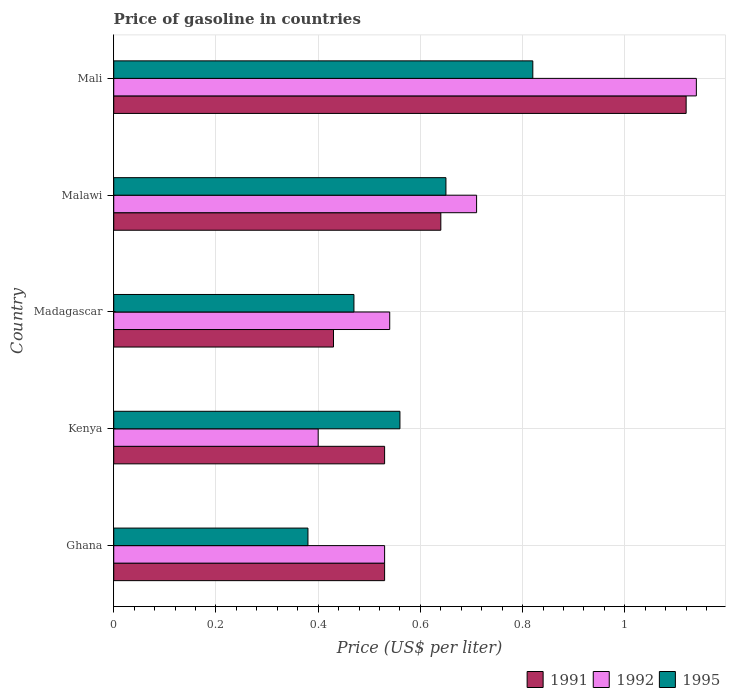Are the number of bars per tick equal to the number of legend labels?
Offer a terse response. Yes. Are the number of bars on each tick of the Y-axis equal?
Offer a very short reply. Yes. How many bars are there on the 4th tick from the top?
Ensure brevity in your answer.  3. How many bars are there on the 2nd tick from the bottom?
Offer a terse response. 3. What is the label of the 1st group of bars from the top?
Provide a succinct answer. Mali. In how many cases, is the number of bars for a given country not equal to the number of legend labels?
Keep it short and to the point. 0. What is the price of gasoline in 1992 in Ghana?
Ensure brevity in your answer.  0.53. Across all countries, what is the maximum price of gasoline in 1991?
Keep it short and to the point. 1.12. Across all countries, what is the minimum price of gasoline in 1991?
Offer a terse response. 0.43. In which country was the price of gasoline in 1992 maximum?
Offer a very short reply. Mali. In which country was the price of gasoline in 1992 minimum?
Provide a short and direct response. Kenya. What is the total price of gasoline in 1991 in the graph?
Keep it short and to the point. 3.25. What is the difference between the price of gasoline in 1995 in Madagascar and that in Mali?
Your response must be concise. -0.35. What is the difference between the price of gasoline in 1991 in Ghana and the price of gasoline in 1992 in Kenya?
Provide a succinct answer. 0.13. What is the average price of gasoline in 1995 per country?
Make the answer very short. 0.58. What is the difference between the price of gasoline in 1992 and price of gasoline in 1991 in Mali?
Your answer should be very brief. 0.02. In how many countries, is the price of gasoline in 1992 greater than 0.44 US$?
Your response must be concise. 4. What is the ratio of the price of gasoline in 1992 in Kenya to that in Madagascar?
Provide a short and direct response. 0.74. Is the price of gasoline in 1995 in Kenya less than that in Madagascar?
Keep it short and to the point. No. Is the difference between the price of gasoline in 1992 in Kenya and Mali greater than the difference between the price of gasoline in 1991 in Kenya and Mali?
Ensure brevity in your answer.  No. What is the difference between the highest and the second highest price of gasoline in 1992?
Keep it short and to the point. 0.43. What is the difference between the highest and the lowest price of gasoline in 1995?
Make the answer very short. 0.44. What does the 1st bar from the bottom in Malawi represents?
Make the answer very short. 1991. Is it the case that in every country, the sum of the price of gasoline in 1995 and price of gasoline in 1992 is greater than the price of gasoline in 1991?
Your answer should be compact. Yes. How many bars are there?
Give a very brief answer. 15. Does the graph contain any zero values?
Offer a very short reply. No. Where does the legend appear in the graph?
Make the answer very short. Bottom right. How many legend labels are there?
Your answer should be compact. 3. What is the title of the graph?
Provide a short and direct response. Price of gasoline in countries. Does "1996" appear as one of the legend labels in the graph?
Offer a very short reply. No. What is the label or title of the X-axis?
Keep it short and to the point. Price (US$ per liter). What is the label or title of the Y-axis?
Offer a very short reply. Country. What is the Price (US$ per liter) in 1991 in Ghana?
Offer a terse response. 0.53. What is the Price (US$ per liter) in 1992 in Ghana?
Your response must be concise. 0.53. What is the Price (US$ per liter) of 1995 in Ghana?
Your answer should be very brief. 0.38. What is the Price (US$ per liter) of 1991 in Kenya?
Your response must be concise. 0.53. What is the Price (US$ per liter) in 1992 in Kenya?
Provide a succinct answer. 0.4. What is the Price (US$ per liter) of 1995 in Kenya?
Provide a succinct answer. 0.56. What is the Price (US$ per liter) of 1991 in Madagascar?
Provide a succinct answer. 0.43. What is the Price (US$ per liter) in 1992 in Madagascar?
Offer a terse response. 0.54. What is the Price (US$ per liter) of 1995 in Madagascar?
Offer a very short reply. 0.47. What is the Price (US$ per liter) of 1991 in Malawi?
Your response must be concise. 0.64. What is the Price (US$ per liter) of 1992 in Malawi?
Make the answer very short. 0.71. What is the Price (US$ per liter) in 1995 in Malawi?
Your answer should be compact. 0.65. What is the Price (US$ per liter) of 1991 in Mali?
Your answer should be compact. 1.12. What is the Price (US$ per liter) of 1992 in Mali?
Offer a very short reply. 1.14. What is the Price (US$ per liter) of 1995 in Mali?
Provide a succinct answer. 0.82. Across all countries, what is the maximum Price (US$ per liter) of 1991?
Offer a very short reply. 1.12. Across all countries, what is the maximum Price (US$ per liter) in 1992?
Provide a short and direct response. 1.14. Across all countries, what is the maximum Price (US$ per liter) in 1995?
Offer a terse response. 0.82. Across all countries, what is the minimum Price (US$ per liter) of 1991?
Your answer should be very brief. 0.43. Across all countries, what is the minimum Price (US$ per liter) of 1992?
Offer a terse response. 0.4. Across all countries, what is the minimum Price (US$ per liter) of 1995?
Your answer should be compact. 0.38. What is the total Price (US$ per liter) in 1992 in the graph?
Give a very brief answer. 3.32. What is the total Price (US$ per liter) in 1995 in the graph?
Offer a terse response. 2.88. What is the difference between the Price (US$ per liter) of 1991 in Ghana and that in Kenya?
Keep it short and to the point. 0. What is the difference between the Price (US$ per liter) in 1992 in Ghana and that in Kenya?
Your answer should be compact. 0.13. What is the difference between the Price (US$ per liter) in 1995 in Ghana and that in Kenya?
Give a very brief answer. -0.18. What is the difference between the Price (US$ per liter) of 1991 in Ghana and that in Madagascar?
Make the answer very short. 0.1. What is the difference between the Price (US$ per liter) of 1992 in Ghana and that in Madagascar?
Your answer should be compact. -0.01. What is the difference between the Price (US$ per liter) of 1995 in Ghana and that in Madagascar?
Your response must be concise. -0.09. What is the difference between the Price (US$ per liter) of 1991 in Ghana and that in Malawi?
Give a very brief answer. -0.11. What is the difference between the Price (US$ per liter) of 1992 in Ghana and that in Malawi?
Your response must be concise. -0.18. What is the difference between the Price (US$ per liter) of 1995 in Ghana and that in Malawi?
Provide a succinct answer. -0.27. What is the difference between the Price (US$ per liter) in 1991 in Ghana and that in Mali?
Offer a terse response. -0.59. What is the difference between the Price (US$ per liter) in 1992 in Ghana and that in Mali?
Provide a succinct answer. -0.61. What is the difference between the Price (US$ per liter) of 1995 in Ghana and that in Mali?
Give a very brief answer. -0.44. What is the difference between the Price (US$ per liter) in 1992 in Kenya and that in Madagascar?
Offer a terse response. -0.14. What is the difference between the Price (US$ per liter) of 1995 in Kenya and that in Madagascar?
Keep it short and to the point. 0.09. What is the difference between the Price (US$ per liter) of 1991 in Kenya and that in Malawi?
Ensure brevity in your answer.  -0.11. What is the difference between the Price (US$ per liter) of 1992 in Kenya and that in Malawi?
Your response must be concise. -0.31. What is the difference between the Price (US$ per liter) of 1995 in Kenya and that in Malawi?
Offer a very short reply. -0.09. What is the difference between the Price (US$ per liter) of 1991 in Kenya and that in Mali?
Your answer should be compact. -0.59. What is the difference between the Price (US$ per liter) of 1992 in Kenya and that in Mali?
Your answer should be compact. -0.74. What is the difference between the Price (US$ per liter) of 1995 in Kenya and that in Mali?
Offer a terse response. -0.26. What is the difference between the Price (US$ per liter) of 1991 in Madagascar and that in Malawi?
Offer a very short reply. -0.21. What is the difference between the Price (US$ per liter) in 1992 in Madagascar and that in Malawi?
Offer a terse response. -0.17. What is the difference between the Price (US$ per liter) of 1995 in Madagascar and that in Malawi?
Keep it short and to the point. -0.18. What is the difference between the Price (US$ per liter) in 1991 in Madagascar and that in Mali?
Provide a succinct answer. -0.69. What is the difference between the Price (US$ per liter) of 1995 in Madagascar and that in Mali?
Provide a succinct answer. -0.35. What is the difference between the Price (US$ per liter) in 1991 in Malawi and that in Mali?
Provide a succinct answer. -0.48. What is the difference between the Price (US$ per liter) of 1992 in Malawi and that in Mali?
Provide a succinct answer. -0.43. What is the difference between the Price (US$ per liter) of 1995 in Malawi and that in Mali?
Offer a terse response. -0.17. What is the difference between the Price (US$ per liter) in 1991 in Ghana and the Price (US$ per liter) in 1992 in Kenya?
Your response must be concise. 0.13. What is the difference between the Price (US$ per liter) in 1991 in Ghana and the Price (US$ per liter) in 1995 in Kenya?
Your answer should be very brief. -0.03. What is the difference between the Price (US$ per liter) in 1992 in Ghana and the Price (US$ per liter) in 1995 in Kenya?
Keep it short and to the point. -0.03. What is the difference between the Price (US$ per liter) of 1991 in Ghana and the Price (US$ per liter) of 1992 in Madagascar?
Provide a short and direct response. -0.01. What is the difference between the Price (US$ per liter) in 1991 in Ghana and the Price (US$ per liter) in 1995 in Madagascar?
Your response must be concise. 0.06. What is the difference between the Price (US$ per liter) of 1992 in Ghana and the Price (US$ per liter) of 1995 in Madagascar?
Your answer should be very brief. 0.06. What is the difference between the Price (US$ per liter) in 1991 in Ghana and the Price (US$ per liter) in 1992 in Malawi?
Offer a very short reply. -0.18. What is the difference between the Price (US$ per liter) of 1991 in Ghana and the Price (US$ per liter) of 1995 in Malawi?
Provide a succinct answer. -0.12. What is the difference between the Price (US$ per liter) in 1992 in Ghana and the Price (US$ per liter) in 1995 in Malawi?
Offer a very short reply. -0.12. What is the difference between the Price (US$ per liter) of 1991 in Ghana and the Price (US$ per liter) of 1992 in Mali?
Ensure brevity in your answer.  -0.61. What is the difference between the Price (US$ per liter) in 1991 in Ghana and the Price (US$ per liter) in 1995 in Mali?
Your answer should be very brief. -0.29. What is the difference between the Price (US$ per liter) in 1992 in Ghana and the Price (US$ per liter) in 1995 in Mali?
Keep it short and to the point. -0.29. What is the difference between the Price (US$ per liter) in 1991 in Kenya and the Price (US$ per liter) in 1992 in Madagascar?
Offer a terse response. -0.01. What is the difference between the Price (US$ per liter) of 1992 in Kenya and the Price (US$ per liter) of 1995 in Madagascar?
Your answer should be very brief. -0.07. What is the difference between the Price (US$ per liter) in 1991 in Kenya and the Price (US$ per liter) in 1992 in Malawi?
Offer a very short reply. -0.18. What is the difference between the Price (US$ per liter) of 1991 in Kenya and the Price (US$ per liter) of 1995 in Malawi?
Your answer should be compact. -0.12. What is the difference between the Price (US$ per liter) of 1992 in Kenya and the Price (US$ per liter) of 1995 in Malawi?
Your response must be concise. -0.25. What is the difference between the Price (US$ per liter) of 1991 in Kenya and the Price (US$ per liter) of 1992 in Mali?
Offer a terse response. -0.61. What is the difference between the Price (US$ per liter) in 1991 in Kenya and the Price (US$ per liter) in 1995 in Mali?
Offer a very short reply. -0.29. What is the difference between the Price (US$ per liter) in 1992 in Kenya and the Price (US$ per liter) in 1995 in Mali?
Provide a short and direct response. -0.42. What is the difference between the Price (US$ per liter) in 1991 in Madagascar and the Price (US$ per liter) in 1992 in Malawi?
Ensure brevity in your answer.  -0.28. What is the difference between the Price (US$ per liter) of 1991 in Madagascar and the Price (US$ per liter) of 1995 in Malawi?
Offer a very short reply. -0.22. What is the difference between the Price (US$ per liter) in 1992 in Madagascar and the Price (US$ per liter) in 1995 in Malawi?
Ensure brevity in your answer.  -0.11. What is the difference between the Price (US$ per liter) in 1991 in Madagascar and the Price (US$ per liter) in 1992 in Mali?
Your answer should be very brief. -0.71. What is the difference between the Price (US$ per liter) in 1991 in Madagascar and the Price (US$ per liter) in 1995 in Mali?
Your answer should be very brief. -0.39. What is the difference between the Price (US$ per liter) of 1992 in Madagascar and the Price (US$ per liter) of 1995 in Mali?
Provide a succinct answer. -0.28. What is the difference between the Price (US$ per liter) in 1991 in Malawi and the Price (US$ per liter) in 1992 in Mali?
Keep it short and to the point. -0.5. What is the difference between the Price (US$ per liter) of 1991 in Malawi and the Price (US$ per liter) of 1995 in Mali?
Make the answer very short. -0.18. What is the difference between the Price (US$ per liter) in 1992 in Malawi and the Price (US$ per liter) in 1995 in Mali?
Keep it short and to the point. -0.11. What is the average Price (US$ per liter) of 1991 per country?
Provide a short and direct response. 0.65. What is the average Price (US$ per liter) in 1992 per country?
Provide a succinct answer. 0.66. What is the average Price (US$ per liter) of 1995 per country?
Your answer should be very brief. 0.58. What is the difference between the Price (US$ per liter) of 1991 and Price (US$ per liter) of 1992 in Ghana?
Offer a terse response. 0. What is the difference between the Price (US$ per liter) in 1991 and Price (US$ per liter) in 1995 in Ghana?
Keep it short and to the point. 0.15. What is the difference between the Price (US$ per liter) in 1991 and Price (US$ per liter) in 1992 in Kenya?
Your answer should be very brief. 0.13. What is the difference between the Price (US$ per liter) of 1991 and Price (US$ per liter) of 1995 in Kenya?
Offer a very short reply. -0.03. What is the difference between the Price (US$ per liter) in 1992 and Price (US$ per liter) in 1995 in Kenya?
Offer a terse response. -0.16. What is the difference between the Price (US$ per liter) of 1991 and Price (US$ per liter) of 1992 in Madagascar?
Give a very brief answer. -0.11. What is the difference between the Price (US$ per liter) in 1991 and Price (US$ per liter) in 1995 in Madagascar?
Your answer should be compact. -0.04. What is the difference between the Price (US$ per liter) in 1992 and Price (US$ per liter) in 1995 in Madagascar?
Your answer should be very brief. 0.07. What is the difference between the Price (US$ per liter) in 1991 and Price (US$ per liter) in 1992 in Malawi?
Your answer should be compact. -0.07. What is the difference between the Price (US$ per liter) in 1991 and Price (US$ per liter) in 1995 in Malawi?
Provide a short and direct response. -0.01. What is the difference between the Price (US$ per liter) in 1991 and Price (US$ per liter) in 1992 in Mali?
Your answer should be compact. -0.02. What is the difference between the Price (US$ per liter) of 1992 and Price (US$ per liter) of 1995 in Mali?
Make the answer very short. 0.32. What is the ratio of the Price (US$ per liter) in 1991 in Ghana to that in Kenya?
Your answer should be very brief. 1. What is the ratio of the Price (US$ per liter) in 1992 in Ghana to that in Kenya?
Ensure brevity in your answer.  1.32. What is the ratio of the Price (US$ per liter) in 1995 in Ghana to that in Kenya?
Ensure brevity in your answer.  0.68. What is the ratio of the Price (US$ per liter) of 1991 in Ghana to that in Madagascar?
Ensure brevity in your answer.  1.23. What is the ratio of the Price (US$ per liter) in 1992 in Ghana to that in Madagascar?
Ensure brevity in your answer.  0.98. What is the ratio of the Price (US$ per liter) in 1995 in Ghana to that in Madagascar?
Provide a short and direct response. 0.81. What is the ratio of the Price (US$ per liter) in 1991 in Ghana to that in Malawi?
Ensure brevity in your answer.  0.83. What is the ratio of the Price (US$ per liter) of 1992 in Ghana to that in Malawi?
Provide a short and direct response. 0.75. What is the ratio of the Price (US$ per liter) in 1995 in Ghana to that in Malawi?
Offer a terse response. 0.58. What is the ratio of the Price (US$ per liter) in 1991 in Ghana to that in Mali?
Provide a succinct answer. 0.47. What is the ratio of the Price (US$ per liter) in 1992 in Ghana to that in Mali?
Offer a very short reply. 0.46. What is the ratio of the Price (US$ per liter) in 1995 in Ghana to that in Mali?
Keep it short and to the point. 0.46. What is the ratio of the Price (US$ per liter) in 1991 in Kenya to that in Madagascar?
Keep it short and to the point. 1.23. What is the ratio of the Price (US$ per liter) of 1992 in Kenya to that in Madagascar?
Offer a terse response. 0.74. What is the ratio of the Price (US$ per liter) of 1995 in Kenya to that in Madagascar?
Your answer should be very brief. 1.19. What is the ratio of the Price (US$ per liter) of 1991 in Kenya to that in Malawi?
Offer a very short reply. 0.83. What is the ratio of the Price (US$ per liter) in 1992 in Kenya to that in Malawi?
Provide a succinct answer. 0.56. What is the ratio of the Price (US$ per liter) in 1995 in Kenya to that in Malawi?
Your answer should be compact. 0.86. What is the ratio of the Price (US$ per liter) in 1991 in Kenya to that in Mali?
Offer a terse response. 0.47. What is the ratio of the Price (US$ per liter) of 1992 in Kenya to that in Mali?
Your response must be concise. 0.35. What is the ratio of the Price (US$ per liter) of 1995 in Kenya to that in Mali?
Provide a succinct answer. 0.68. What is the ratio of the Price (US$ per liter) in 1991 in Madagascar to that in Malawi?
Your answer should be very brief. 0.67. What is the ratio of the Price (US$ per liter) in 1992 in Madagascar to that in Malawi?
Your response must be concise. 0.76. What is the ratio of the Price (US$ per liter) of 1995 in Madagascar to that in Malawi?
Your answer should be compact. 0.72. What is the ratio of the Price (US$ per liter) in 1991 in Madagascar to that in Mali?
Your response must be concise. 0.38. What is the ratio of the Price (US$ per liter) in 1992 in Madagascar to that in Mali?
Give a very brief answer. 0.47. What is the ratio of the Price (US$ per liter) in 1995 in Madagascar to that in Mali?
Keep it short and to the point. 0.57. What is the ratio of the Price (US$ per liter) of 1991 in Malawi to that in Mali?
Provide a succinct answer. 0.57. What is the ratio of the Price (US$ per liter) of 1992 in Malawi to that in Mali?
Keep it short and to the point. 0.62. What is the ratio of the Price (US$ per liter) in 1995 in Malawi to that in Mali?
Your response must be concise. 0.79. What is the difference between the highest and the second highest Price (US$ per liter) of 1991?
Provide a short and direct response. 0.48. What is the difference between the highest and the second highest Price (US$ per liter) in 1992?
Your response must be concise. 0.43. What is the difference between the highest and the second highest Price (US$ per liter) of 1995?
Give a very brief answer. 0.17. What is the difference between the highest and the lowest Price (US$ per liter) in 1991?
Your answer should be compact. 0.69. What is the difference between the highest and the lowest Price (US$ per liter) of 1992?
Provide a succinct answer. 0.74. What is the difference between the highest and the lowest Price (US$ per liter) in 1995?
Keep it short and to the point. 0.44. 